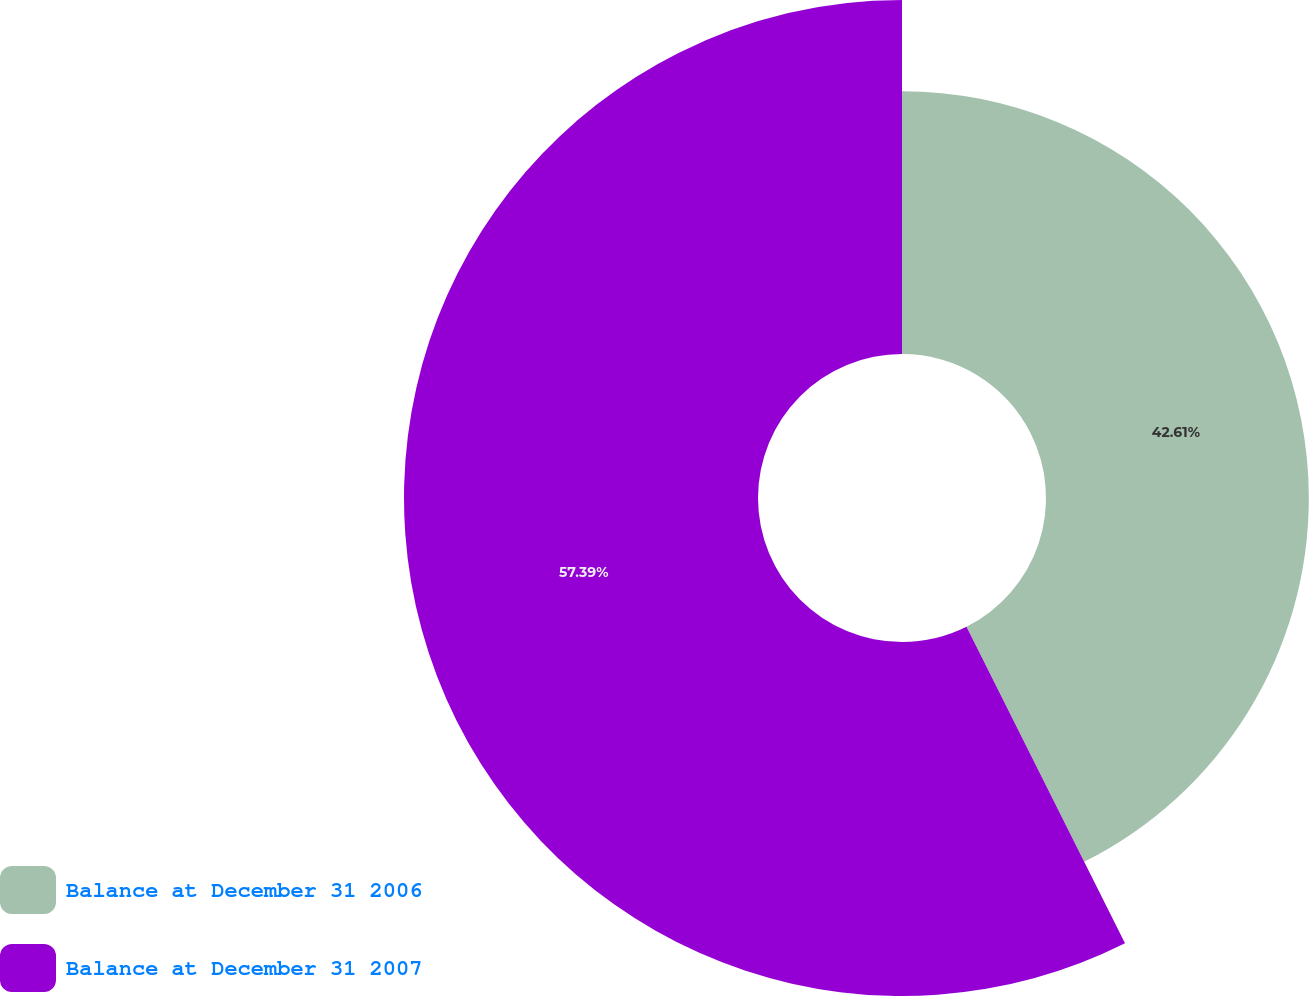<chart> <loc_0><loc_0><loc_500><loc_500><pie_chart><fcel>Balance at December 31 2006<fcel>Balance at December 31 2007<nl><fcel>42.61%<fcel>57.39%<nl></chart> 